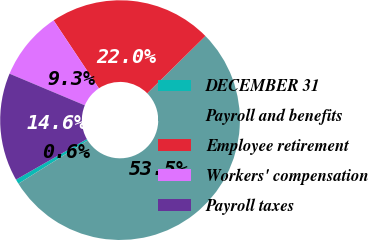Convert chart to OTSL. <chart><loc_0><loc_0><loc_500><loc_500><pie_chart><fcel>DECEMBER 31<fcel>Payroll and benefits<fcel>Employee retirement<fcel>Workers' compensation<fcel>Payroll taxes<nl><fcel>0.63%<fcel>53.49%<fcel>21.97%<fcel>9.32%<fcel>14.6%<nl></chart> 